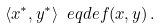<formula> <loc_0><loc_0><loc_500><loc_500>\langle x ^ { \ast } , y ^ { \ast } \rangle \ e q d e f ( x , y ) \, .</formula> 